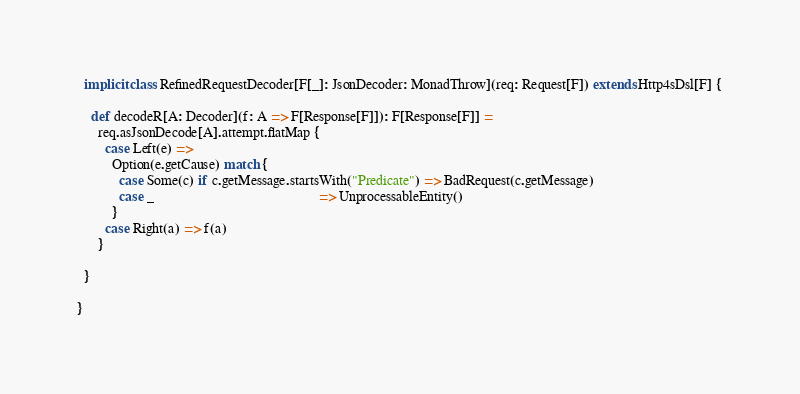Convert code to text. <code><loc_0><loc_0><loc_500><loc_500><_Scala_>  implicit class RefinedRequestDecoder[F[_]: JsonDecoder: MonadThrow](req: Request[F]) extends Http4sDsl[F] {

    def decodeR[A: Decoder](f: A => F[Response[F]]): F[Response[F]] =
      req.asJsonDecode[A].attempt.flatMap {
        case Left(e) =>
          Option(e.getCause) match {
            case Some(c) if c.getMessage.startsWith("Predicate") => BadRequest(c.getMessage)
            case _                                               => UnprocessableEntity()
          }
        case Right(a) => f(a)
      }

  }

}
</code> 